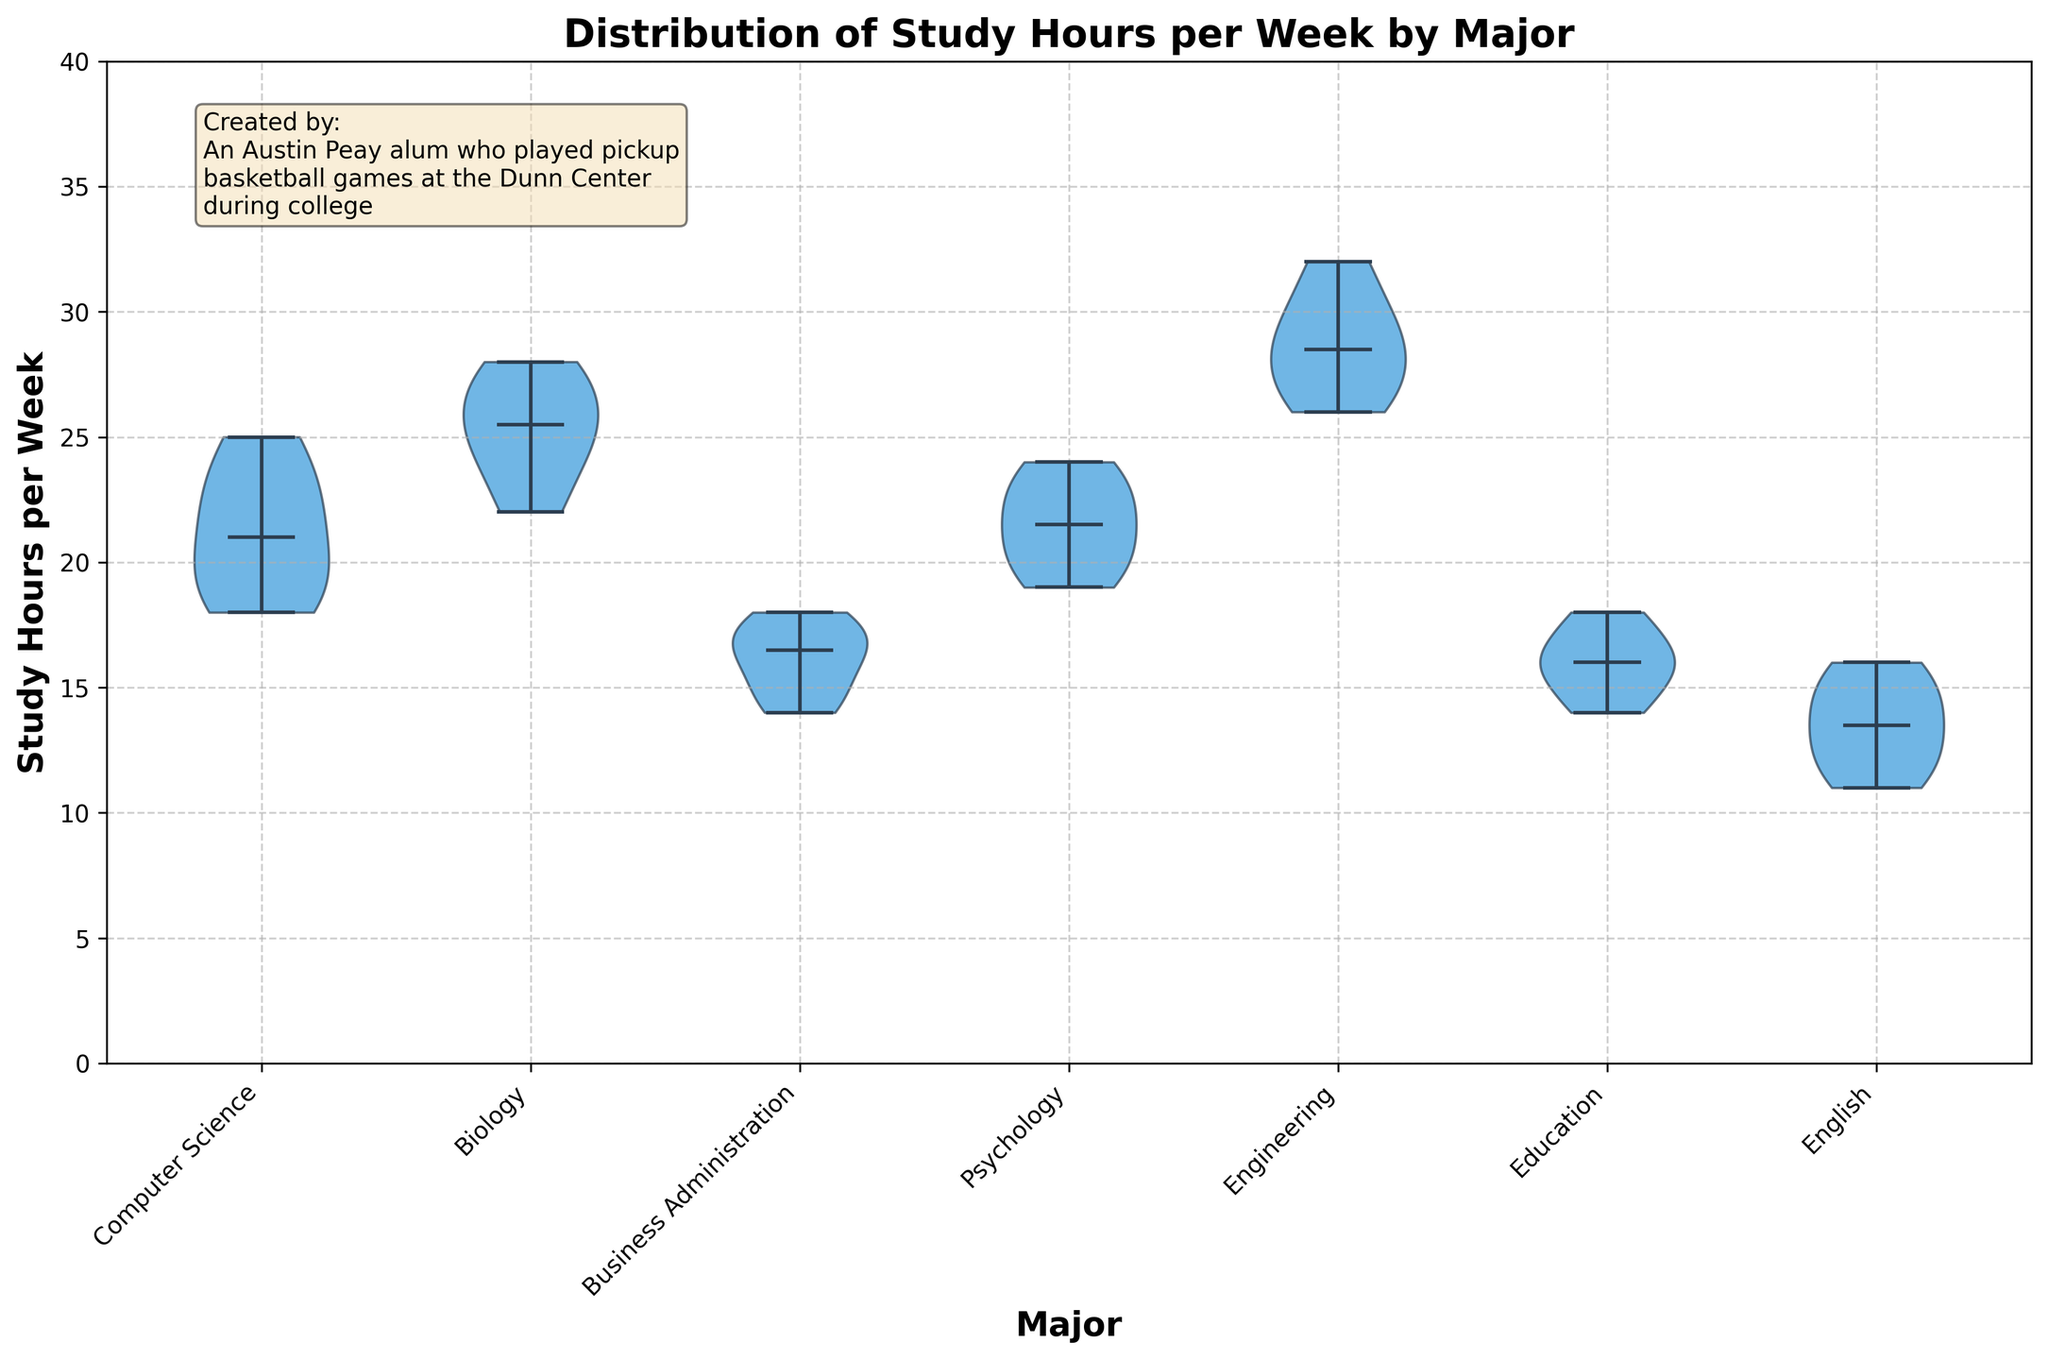What is the title of the figure? The title is situated at the top of the figure. It reads "Distribution of Study Hours per Week by Major".
Answer: Distribution of Study Hours per Week by Major Which major has the highest median study hours per week? By visually inspecting the horizontal lines (medians) within each violin plot, Engineering has the highest median line compared to other majors.
Answer: Engineering What is the median study hours per week for Computer Science majors? The median is represented by the horizontal line within the violin plot for Computer Science. Checking this plot shows a median around 22 hours.
Answer: 22 hours Is there any major with study hours per week spanning from 10 to 40 hours? Look at the range (from bottom to top) for each violin plot. None of the distributions span from 10-40 hours. The closest is Engineering, spanning roughly from 26 to 32 hours.
Answer: No Which major shows the widest distribution in study hours per week? Evaluate the widths of the violin plots. Engineering has the widest spread, indicating varied study hours among its students.
Answer: Engineering Compare the median study hours per week between Psychology and English majors. Which is higher? The horizontal median lines for Psychology and English can be compared. Psychology has a higher median compared to English.
Answer: Psychology For which major is the range of study hours per week the narrowest? This can be identified by the violin plot with the smallest vertical extent. English appears to have the narrowest range.
Answer: English How do the median study hours per week for Business Administration compare to Education? Compare the medians directly by looking at their horizontal lines. Business Administration's line is slightly lower than Education’s.
Answer: Education Which major has students studying closer to the median value? By evaluating the density and spread in the violin plots, English has a higher concentration near the median, indicating students study closer to the median value.
Answer: English Are there any majors that show study hours below 15? If yes, which ones? Check the lowest points of each violin plot. English, Business Administration, and Education all show study hours below 15.
Answer: English, Business Administration, Education 